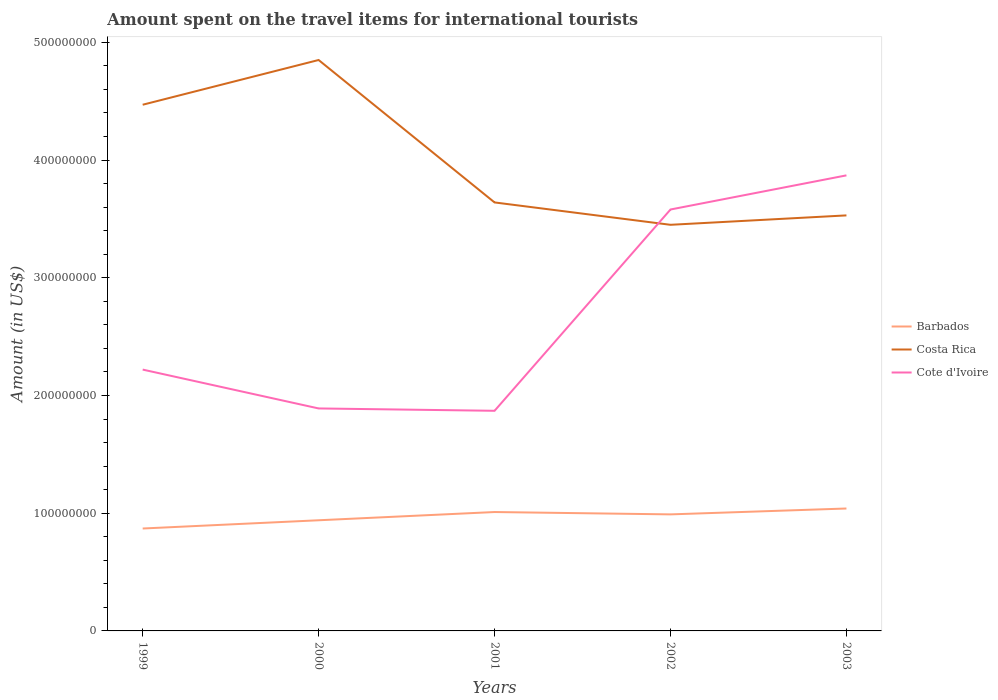Does the line corresponding to Costa Rica intersect with the line corresponding to Barbados?
Keep it short and to the point. No. Is the number of lines equal to the number of legend labels?
Your response must be concise. Yes. Across all years, what is the maximum amount spent on the travel items for international tourists in Costa Rica?
Provide a succinct answer. 3.45e+08. In which year was the amount spent on the travel items for international tourists in Costa Rica maximum?
Your answer should be compact. 2002. What is the total amount spent on the travel items for international tourists in Barbados in the graph?
Make the answer very short. -5.00e+06. What is the difference between the highest and the second highest amount spent on the travel items for international tourists in Barbados?
Provide a succinct answer. 1.70e+07. How many lines are there?
Ensure brevity in your answer.  3. What is the difference between two consecutive major ticks on the Y-axis?
Provide a short and direct response. 1.00e+08. Are the values on the major ticks of Y-axis written in scientific E-notation?
Your answer should be compact. No. Where does the legend appear in the graph?
Ensure brevity in your answer.  Center right. How are the legend labels stacked?
Your response must be concise. Vertical. What is the title of the graph?
Offer a very short reply. Amount spent on the travel items for international tourists. Does "Azerbaijan" appear as one of the legend labels in the graph?
Provide a short and direct response. No. What is the label or title of the X-axis?
Offer a very short reply. Years. What is the Amount (in US$) in Barbados in 1999?
Your answer should be very brief. 8.70e+07. What is the Amount (in US$) in Costa Rica in 1999?
Provide a short and direct response. 4.47e+08. What is the Amount (in US$) in Cote d'Ivoire in 1999?
Offer a very short reply. 2.22e+08. What is the Amount (in US$) in Barbados in 2000?
Offer a terse response. 9.40e+07. What is the Amount (in US$) of Costa Rica in 2000?
Offer a very short reply. 4.85e+08. What is the Amount (in US$) in Cote d'Ivoire in 2000?
Provide a short and direct response. 1.89e+08. What is the Amount (in US$) in Barbados in 2001?
Ensure brevity in your answer.  1.01e+08. What is the Amount (in US$) of Costa Rica in 2001?
Offer a terse response. 3.64e+08. What is the Amount (in US$) in Cote d'Ivoire in 2001?
Offer a terse response. 1.87e+08. What is the Amount (in US$) in Barbados in 2002?
Provide a short and direct response. 9.90e+07. What is the Amount (in US$) in Costa Rica in 2002?
Offer a very short reply. 3.45e+08. What is the Amount (in US$) in Cote d'Ivoire in 2002?
Your response must be concise. 3.58e+08. What is the Amount (in US$) in Barbados in 2003?
Keep it short and to the point. 1.04e+08. What is the Amount (in US$) of Costa Rica in 2003?
Give a very brief answer. 3.53e+08. What is the Amount (in US$) in Cote d'Ivoire in 2003?
Keep it short and to the point. 3.87e+08. Across all years, what is the maximum Amount (in US$) in Barbados?
Ensure brevity in your answer.  1.04e+08. Across all years, what is the maximum Amount (in US$) of Costa Rica?
Ensure brevity in your answer.  4.85e+08. Across all years, what is the maximum Amount (in US$) in Cote d'Ivoire?
Make the answer very short. 3.87e+08. Across all years, what is the minimum Amount (in US$) of Barbados?
Provide a succinct answer. 8.70e+07. Across all years, what is the minimum Amount (in US$) in Costa Rica?
Your answer should be compact. 3.45e+08. Across all years, what is the minimum Amount (in US$) of Cote d'Ivoire?
Offer a terse response. 1.87e+08. What is the total Amount (in US$) of Barbados in the graph?
Offer a terse response. 4.85e+08. What is the total Amount (in US$) of Costa Rica in the graph?
Keep it short and to the point. 1.99e+09. What is the total Amount (in US$) in Cote d'Ivoire in the graph?
Your answer should be very brief. 1.34e+09. What is the difference between the Amount (in US$) in Barbados in 1999 and that in 2000?
Provide a succinct answer. -7.00e+06. What is the difference between the Amount (in US$) in Costa Rica in 1999 and that in 2000?
Give a very brief answer. -3.80e+07. What is the difference between the Amount (in US$) in Cote d'Ivoire in 1999 and that in 2000?
Offer a very short reply. 3.30e+07. What is the difference between the Amount (in US$) of Barbados in 1999 and that in 2001?
Give a very brief answer. -1.40e+07. What is the difference between the Amount (in US$) of Costa Rica in 1999 and that in 2001?
Your answer should be very brief. 8.30e+07. What is the difference between the Amount (in US$) of Cote d'Ivoire in 1999 and that in 2001?
Provide a short and direct response. 3.50e+07. What is the difference between the Amount (in US$) of Barbados in 1999 and that in 2002?
Your answer should be compact. -1.20e+07. What is the difference between the Amount (in US$) in Costa Rica in 1999 and that in 2002?
Offer a very short reply. 1.02e+08. What is the difference between the Amount (in US$) in Cote d'Ivoire in 1999 and that in 2002?
Provide a short and direct response. -1.36e+08. What is the difference between the Amount (in US$) of Barbados in 1999 and that in 2003?
Keep it short and to the point. -1.70e+07. What is the difference between the Amount (in US$) in Costa Rica in 1999 and that in 2003?
Your answer should be compact. 9.40e+07. What is the difference between the Amount (in US$) in Cote d'Ivoire in 1999 and that in 2003?
Provide a short and direct response. -1.65e+08. What is the difference between the Amount (in US$) in Barbados in 2000 and that in 2001?
Provide a succinct answer. -7.00e+06. What is the difference between the Amount (in US$) in Costa Rica in 2000 and that in 2001?
Your answer should be compact. 1.21e+08. What is the difference between the Amount (in US$) in Barbados in 2000 and that in 2002?
Provide a succinct answer. -5.00e+06. What is the difference between the Amount (in US$) of Costa Rica in 2000 and that in 2002?
Ensure brevity in your answer.  1.40e+08. What is the difference between the Amount (in US$) in Cote d'Ivoire in 2000 and that in 2002?
Provide a succinct answer. -1.69e+08. What is the difference between the Amount (in US$) of Barbados in 2000 and that in 2003?
Your answer should be very brief. -1.00e+07. What is the difference between the Amount (in US$) in Costa Rica in 2000 and that in 2003?
Ensure brevity in your answer.  1.32e+08. What is the difference between the Amount (in US$) in Cote d'Ivoire in 2000 and that in 2003?
Give a very brief answer. -1.98e+08. What is the difference between the Amount (in US$) in Costa Rica in 2001 and that in 2002?
Ensure brevity in your answer.  1.90e+07. What is the difference between the Amount (in US$) of Cote d'Ivoire in 2001 and that in 2002?
Give a very brief answer. -1.71e+08. What is the difference between the Amount (in US$) in Barbados in 2001 and that in 2003?
Give a very brief answer. -3.00e+06. What is the difference between the Amount (in US$) of Costa Rica in 2001 and that in 2003?
Offer a very short reply. 1.10e+07. What is the difference between the Amount (in US$) of Cote d'Ivoire in 2001 and that in 2003?
Offer a very short reply. -2.00e+08. What is the difference between the Amount (in US$) in Barbados in 2002 and that in 2003?
Offer a very short reply. -5.00e+06. What is the difference between the Amount (in US$) in Costa Rica in 2002 and that in 2003?
Ensure brevity in your answer.  -8.00e+06. What is the difference between the Amount (in US$) in Cote d'Ivoire in 2002 and that in 2003?
Make the answer very short. -2.90e+07. What is the difference between the Amount (in US$) of Barbados in 1999 and the Amount (in US$) of Costa Rica in 2000?
Make the answer very short. -3.98e+08. What is the difference between the Amount (in US$) in Barbados in 1999 and the Amount (in US$) in Cote d'Ivoire in 2000?
Provide a short and direct response. -1.02e+08. What is the difference between the Amount (in US$) of Costa Rica in 1999 and the Amount (in US$) of Cote d'Ivoire in 2000?
Provide a short and direct response. 2.58e+08. What is the difference between the Amount (in US$) of Barbados in 1999 and the Amount (in US$) of Costa Rica in 2001?
Provide a short and direct response. -2.77e+08. What is the difference between the Amount (in US$) in Barbados in 1999 and the Amount (in US$) in Cote d'Ivoire in 2001?
Your response must be concise. -1.00e+08. What is the difference between the Amount (in US$) in Costa Rica in 1999 and the Amount (in US$) in Cote d'Ivoire in 2001?
Provide a succinct answer. 2.60e+08. What is the difference between the Amount (in US$) in Barbados in 1999 and the Amount (in US$) in Costa Rica in 2002?
Your response must be concise. -2.58e+08. What is the difference between the Amount (in US$) of Barbados in 1999 and the Amount (in US$) of Cote d'Ivoire in 2002?
Make the answer very short. -2.71e+08. What is the difference between the Amount (in US$) in Costa Rica in 1999 and the Amount (in US$) in Cote d'Ivoire in 2002?
Your answer should be very brief. 8.90e+07. What is the difference between the Amount (in US$) of Barbados in 1999 and the Amount (in US$) of Costa Rica in 2003?
Keep it short and to the point. -2.66e+08. What is the difference between the Amount (in US$) of Barbados in 1999 and the Amount (in US$) of Cote d'Ivoire in 2003?
Provide a succinct answer. -3.00e+08. What is the difference between the Amount (in US$) of Costa Rica in 1999 and the Amount (in US$) of Cote d'Ivoire in 2003?
Offer a terse response. 6.00e+07. What is the difference between the Amount (in US$) in Barbados in 2000 and the Amount (in US$) in Costa Rica in 2001?
Ensure brevity in your answer.  -2.70e+08. What is the difference between the Amount (in US$) of Barbados in 2000 and the Amount (in US$) of Cote d'Ivoire in 2001?
Keep it short and to the point. -9.30e+07. What is the difference between the Amount (in US$) of Costa Rica in 2000 and the Amount (in US$) of Cote d'Ivoire in 2001?
Give a very brief answer. 2.98e+08. What is the difference between the Amount (in US$) in Barbados in 2000 and the Amount (in US$) in Costa Rica in 2002?
Your response must be concise. -2.51e+08. What is the difference between the Amount (in US$) of Barbados in 2000 and the Amount (in US$) of Cote d'Ivoire in 2002?
Offer a very short reply. -2.64e+08. What is the difference between the Amount (in US$) of Costa Rica in 2000 and the Amount (in US$) of Cote d'Ivoire in 2002?
Provide a succinct answer. 1.27e+08. What is the difference between the Amount (in US$) of Barbados in 2000 and the Amount (in US$) of Costa Rica in 2003?
Give a very brief answer. -2.59e+08. What is the difference between the Amount (in US$) in Barbados in 2000 and the Amount (in US$) in Cote d'Ivoire in 2003?
Your answer should be very brief. -2.93e+08. What is the difference between the Amount (in US$) of Costa Rica in 2000 and the Amount (in US$) of Cote d'Ivoire in 2003?
Make the answer very short. 9.80e+07. What is the difference between the Amount (in US$) of Barbados in 2001 and the Amount (in US$) of Costa Rica in 2002?
Ensure brevity in your answer.  -2.44e+08. What is the difference between the Amount (in US$) of Barbados in 2001 and the Amount (in US$) of Cote d'Ivoire in 2002?
Offer a very short reply. -2.57e+08. What is the difference between the Amount (in US$) in Costa Rica in 2001 and the Amount (in US$) in Cote d'Ivoire in 2002?
Keep it short and to the point. 6.00e+06. What is the difference between the Amount (in US$) in Barbados in 2001 and the Amount (in US$) in Costa Rica in 2003?
Your answer should be compact. -2.52e+08. What is the difference between the Amount (in US$) of Barbados in 2001 and the Amount (in US$) of Cote d'Ivoire in 2003?
Your answer should be very brief. -2.86e+08. What is the difference between the Amount (in US$) of Costa Rica in 2001 and the Amount (in US$) of Cote d'Ivoire in 2003?
Your answer should be very brief. -2.30e+07. What is the difference between the Amount (in US$) in Barbados in 2002 and the Amount (in US$) in Costa Rica in 2003?
Keep it short and to the point. -2.54e+08. What is the difference between the Amount (in US$) in Barbados in 2002 and the Amount (in US$) in Cote d'Ivoire in 2003?
Your answer should be compact. -2.88e+08. What is the difference between the Amount (in US$) of Costa Rica in 2002 and the Amount (in US$) of Cote d'Ivoire in 2003?
Make the answer very short. -4.20e+07. What is the average Amount (in US$) in Barbados per year?
Your answer should be compact. 9.70e+07. What is the average Amount (in US$) in Costa Rica per year?
Offer a terse response. 3.99e+08. What is the average Amount (in US$) of Cote d'Ivoire per year?
Keep it short and to the point. 2.69e+08. In the year 1999, what is the difference between the Amount (in US$) of Barbados and Amount (in US$) of Costa Rica?
Offer a very short reply. -3.60e+08. In the year 1999, what is the difference between the Amount (in US$) of Barbados and Amount (in US$) of Cote d'Ivoire?
Keep it short and to the point. -1.35e+08. In the year 1999, what is the difference between the Amount (in US$) in Costa Rica and Amount (in US$) in Cote d'Ivoire?
Keep it short and to the point. 2.25e+08. In the year 2000, what is the difference between the Amount (in US$) in Barbados and Amount (in US$) in Costa Rica?
Offer a very short reply. -3.91e+08. In the year 2000, what is the difference between the Amount (in US$) of Barbados and Amount (in US$) of Cote d'Ivoire?
Offer a very short reply. -9.50e+07. In the year 2000, what is the difference between the Amount (in US$) of Costa Rica and Amount (in US$) of Cote d'Ivoire?
Your response must be concise. 2.96e+08. In the year 2001, what is the difference between the Amount (in US$) in Barbados and Amount (in US$) in Costa Rica?
Offer a very short reply. -2.63e+08. In the year 2001, what is the difference between the Amount (in US$) of Barbados and Amount (in US$) of Cote d'Ivoire?
Your response must be concise. -8.60e+07. In the year 2001, what is the difference between the Amount (in US$) in Costa Rica and Amount (in US$) in Cote d'Ivoire?
Make the answer very short. 1.77e+08. In the year 2002, what is the difference between the Amount (in US$) in Barbados and Amount (in US$) in Costa Rica?
Offer a terse response. -2.46e+08. In the year 2002, what is the difference between the Amount (in US$) of Barbados and Amount (in US$) of Cote d'Ivoire?
Give a very brief answer. -2.59e+08. In the year 2002, what is the difference between the Amount (in US$) in Costa Rica and Amount (in US$) in Cote d'Ivoire?
Give a very brief answer. -1.30e+07. In the year 2003, what is the difference between the Amount (in US$) of Barbados and Amount (in US$) of Costa Rica?
Provide a succinct answer. -2.49e+08. In the year 2003, what is the difference between the Amount (in US$) of Barbados and Amount (in US$) of Cote d'Ivoire?
Keep it short and to the point. -2.83e+08. In the year 2003, what is the difference between the Amount (in US$) in Costa Rica and Amount (in US$) in Cote d'Ivoire?
Provide a succinct answer. -3.40e+07. What is the ratio of the Amount (in US$) of Barbados in 1999 to that in 2000?
Offer a very short reply. 0.93. What is the ratio of the Amount (in US$) in Costa Rica in 1999 to that in 2000?
Your answer should be compact. 0.92. What is the ratio of the Amount (in US$) of Cote d'Ivoire in 1999 to that in 2000?
Provide a succinct answer. 1.17. What is the ratio of the Amount (in US$) in Barbados in 1999 to that in 2001?
Give a very brief answer. 0.86. What is the ratio of the Amount (in US$) of Costa Rica in 1999 to that in 2001?
Your response must be concise. 1.23. What is the ratio of the Amount (in US$) of Cote d'Ivoire in 1999 to that in 2001?
Your answer should be very brief. 1.19. What is the ratio of the Amount (in US$) of Barbados in 1999 to that in 2002?
Provide a short and direct response. 0.88. What is the ratio of the Amount (in US$) in Costa Rica in 1999 to that in 2002?
Offer a terse response. 1.3. What is the ratio of the Amount (in US$) in Cote d'Ivoire in 1999 to that in 2002?
Provide a short and direct response. 0.62. What is the ratio of the Amount (in US$) in Barbados in 1999 to that in 2003?
Your answer should be very brief. 0.84. What is the ratio of the Amount (in US$) of Costa Rica in 1999 to that in 2003?
Offer a terse response. 1.27. What is the ratio of the Amount (in US$) in Cote d'Ivoire in 1999 to that in 2003?
Provide a short and direct response. 0.57. What is the ratio of the Amount (in US$) of Barbados in 2000 to that in 2001?
Your answer should be compact. 0.93. What is the ratio of the Amount (in US$) of Costa Rica in 2000 to that in 2001?
Ensure brevity in your answer.  1.33. What is the ratio of the Amount (in US$) of Cote d'Ivoire in 2000 to that in 2001?
Make the answer very short. 1.01. What is the ratio of the Amount (in US$) of Barbados in 2000 to that in 2002?
Your answer should be very brief. 0.95. What is the ratio of the Amount (in US$) of Costa Rica in 2000 to that in 2002?
Keep it short and to the point. 1.41. What is the ratio of the Amount (in US$) in Cote d'Ivoire in 2000 to that in 2002?
Make the answer very short. 0.53. What is the ratio of the Amount (in US$) of Barbados in 2000 to that in 2003?
Provide a succinct answer. 0.9. What is the ratio of the Amount (in US$) of Costa Rica in 2000 to that in 2003?
Make the answer very short. 1.37. What is the ratio of the Amount (in US$) in Cote d'Ivoire in 2000 to that in 2003?
Provide a succinct answer. 0.49. What is the ratio of the Amount (in US$) in Barbados in 2001 to that in 2002?
Offer a terse response. 1.02. What is the ratio of the Amount (in US$) in Costa Rica in 2001 to that in 2002?
Keep it short and to the point. 1.06. What is the ratio of the Amount (in US$) in Cote d'Ivoire in 2001 to that in 2002?
Your answer should be very brief. 0.52. What is the ratio of the Amount (in US$) of Barbados in 2001 to that in 2003?
Make the answer very short. 0.97. What is the ratio of the Amount (in US$) in Costa Rica in 2001 to that in 2003?
Your answer should be very brief. 1.03. What is the ratio of the Amount (in US$) in Cote d'Ivoire in 2001 to that in 2003?
Give a very brief answer. 0.48. What is the ratio of the Amount (in US$) of Barbados in 2002 to that in 2003?
Offer a very short reply. 0.95. What is the ratio of the Amount (in US$) of Costa Rica in 2002 to that in 2003?
Your answer should be compact. 0.98. What is the ratio of the Amount (in US$) of Cote d'Ivoire in 2002 to that in 2003?
Make the answer very short. 0.93. What is the difference between the highest and the second highest Amount (in US$) of Costa Rica?
Ensure brevity in your answer.  3.80e+07. What is the difference between the highest and the second highest Amount (in US$) in Cote d'Ivoire?
Keep it short and to the point. 2.90e+07. What is the difference between the highest and the lowest Amount (in US$) of Barbados?
Provide a succinct answer. 1.70e+07. What is the difference between the highest and the lowest Amount (in US$) in Costa Rica?
Ensure brevity in your answer.  1.40e+08. 